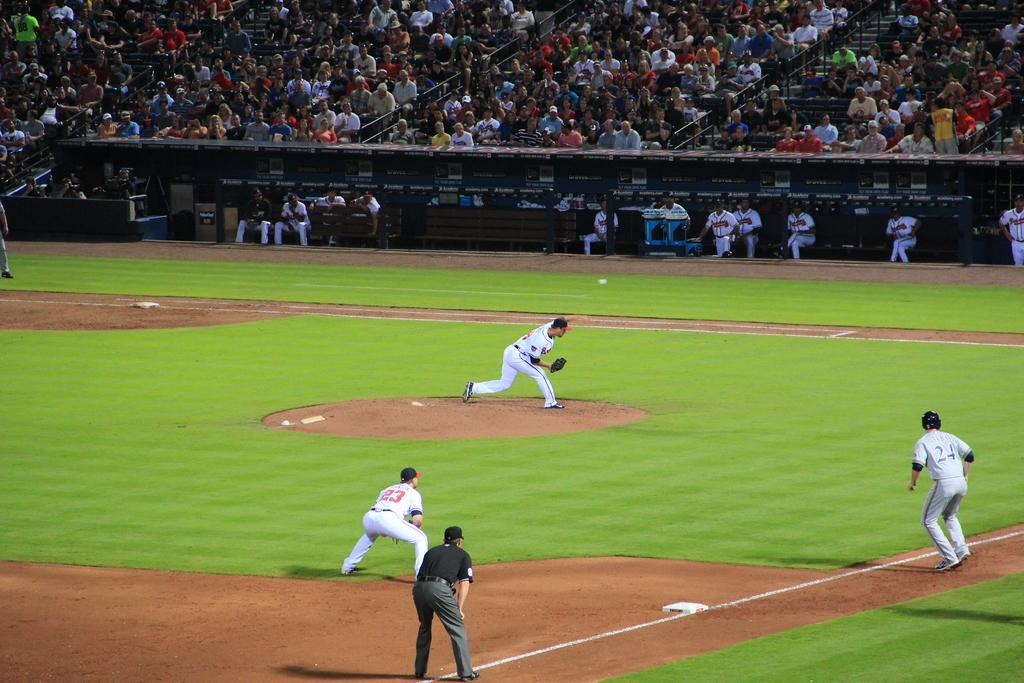Provide a one-sentence caption for the provided image. The pitcher throws a ball during a baseball game. 